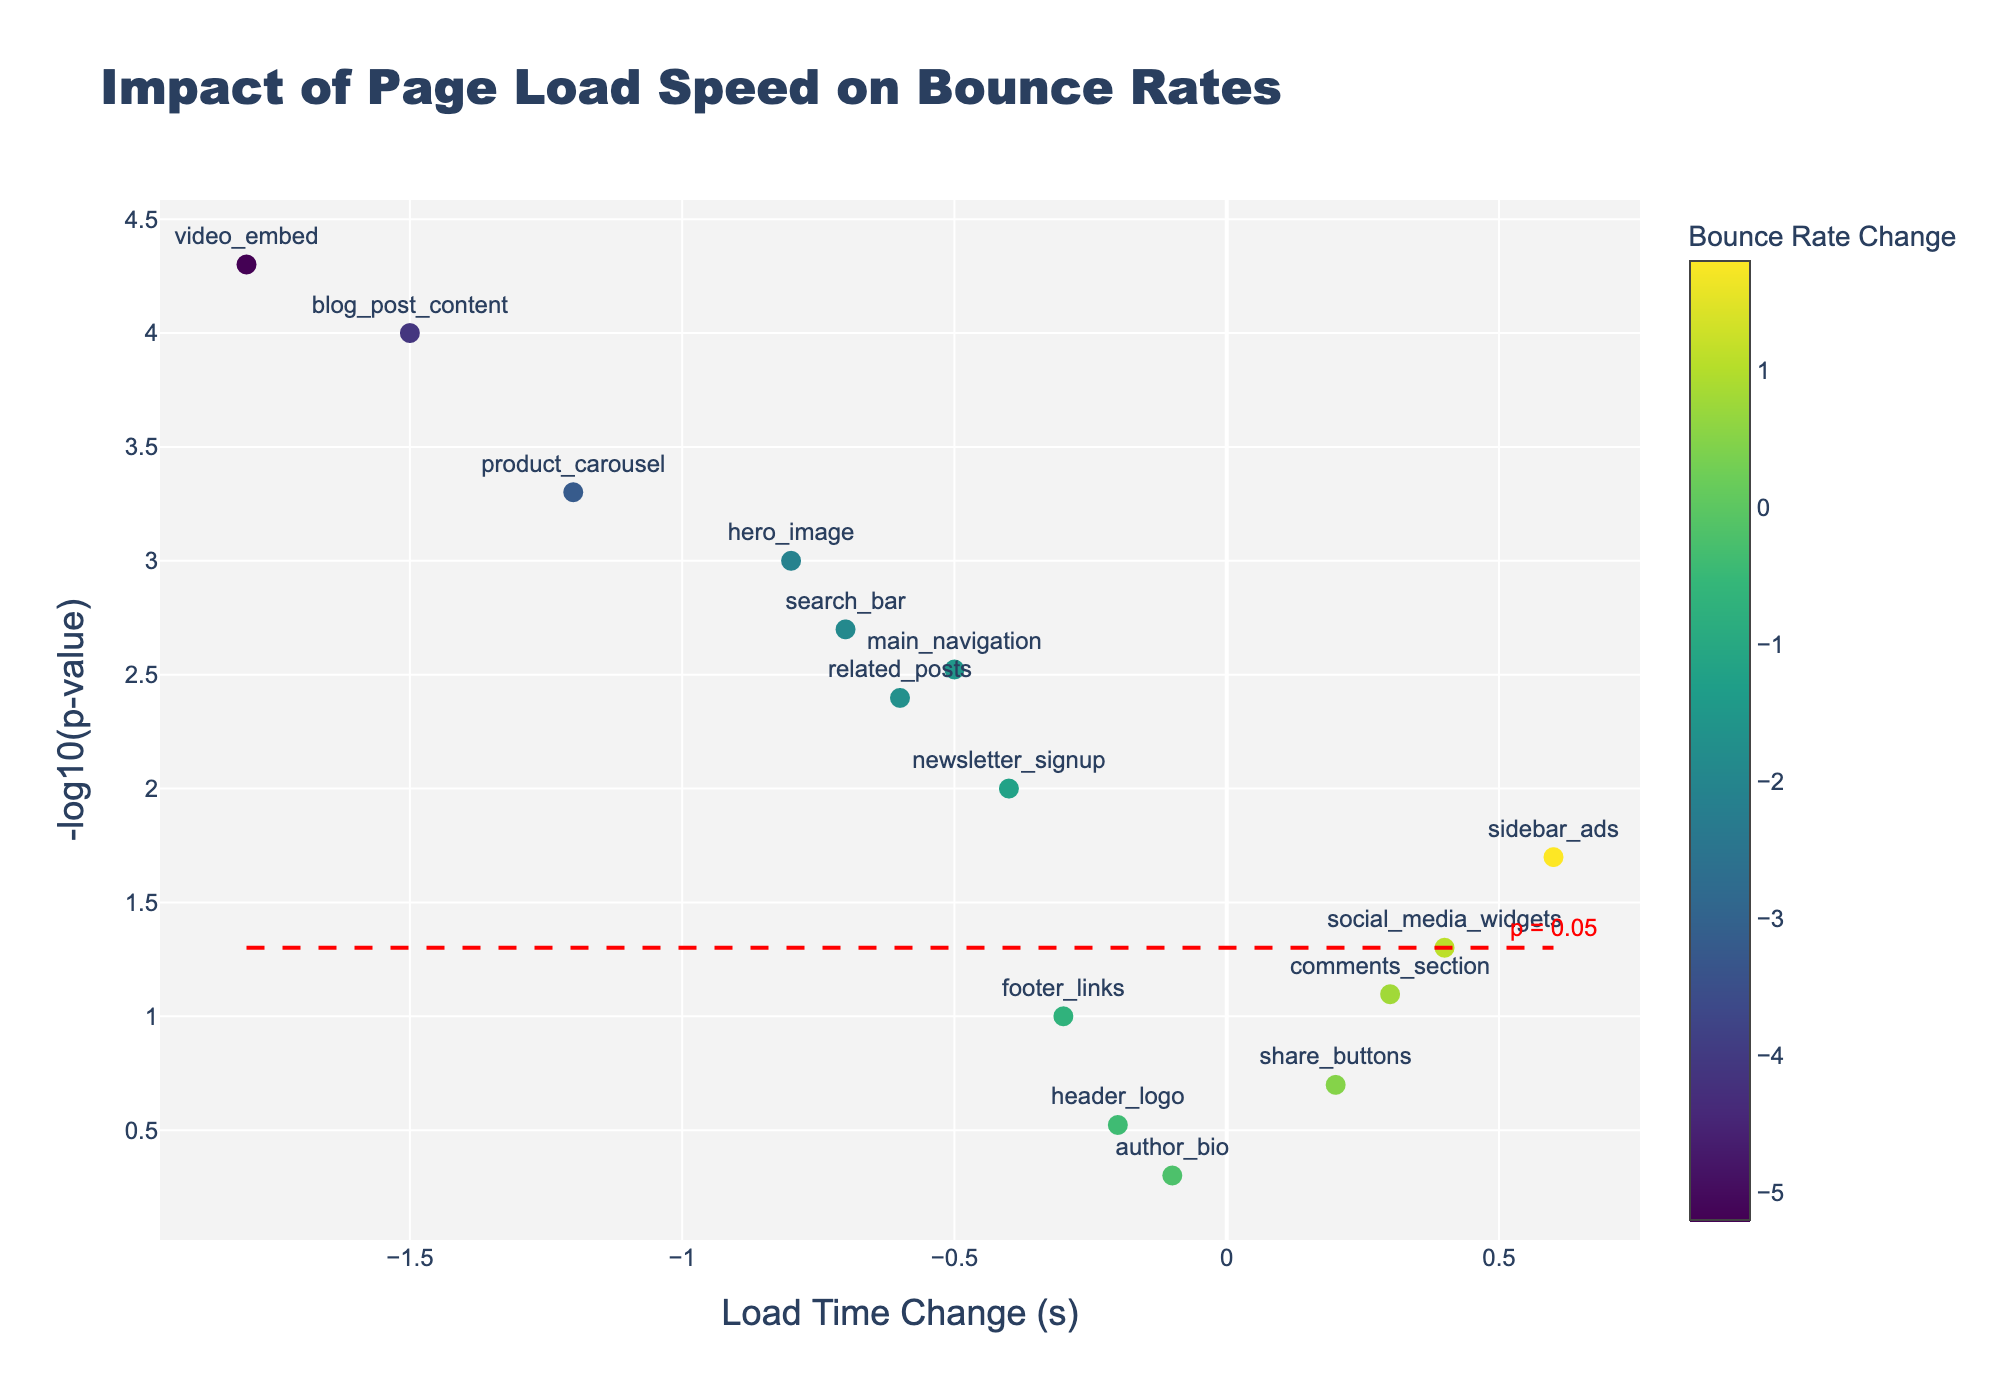What's the title of the figure? The title of the figure is prominently displayed at the top.
Answer: Impact of Page Load Speed on Bounce Rates What's on the x-axis of the plot? The x-axis title is given below the horizontal axis in the plot.
Answer: Load Time Change (s) What's the color scale used in the plot? The color scale represents the bounce rate change and is shown on the color bar with a title indicating its meaning.
Answer: Viridis How many elements have a significant impact on bounce rates (p < 0.05)? The red dashed line indicates the p-value significance threshold (p = 0.05). Count the number of data points above this line.
Answer: 10 Which page element has the most significant impact on bounce rates? The data point farthest from the x-axis and above the red dashed line indicates the most significant impact, due to its highest -log10(p-value).
Answer: video_embed Which elements show a negative change in both load time and bounce rate? Identify data points in the plot where the load time change and bounce rate change are both negative.
Answer: hero_image, main_navigation, product_carousel, search_bar, blog_post_content, related_posts, video_embed What is the logical operation required to determine the most significant elements affecting bounce rates? Evaluate the ones with the highest -log10(p-value) while also being above the red dashed significance threshold line.
Answer: Compare -log10(p-value) What is the relationship between 'sidebar_ads' and 'related_posts' in terms of load time change? Compare the x-axis positions of 'sidebar_ads' and 'related_posts'.
Answer: sidebar_ads load time change is greater than related_posts Between ‘hero_image’ and ‘social_media_widgets’, which element shows a greater decrease in bounce rate? Check the color bar to compare the bounce rate change colors of both elements.
Answer: hero_image How is the significance threshold indicated in the plot? The plot includes a red dashed line and an annotation text 'p = 0.05' to indicate the threshold.
Answer: Red dashed line at -log10(p-value) of 0.05 